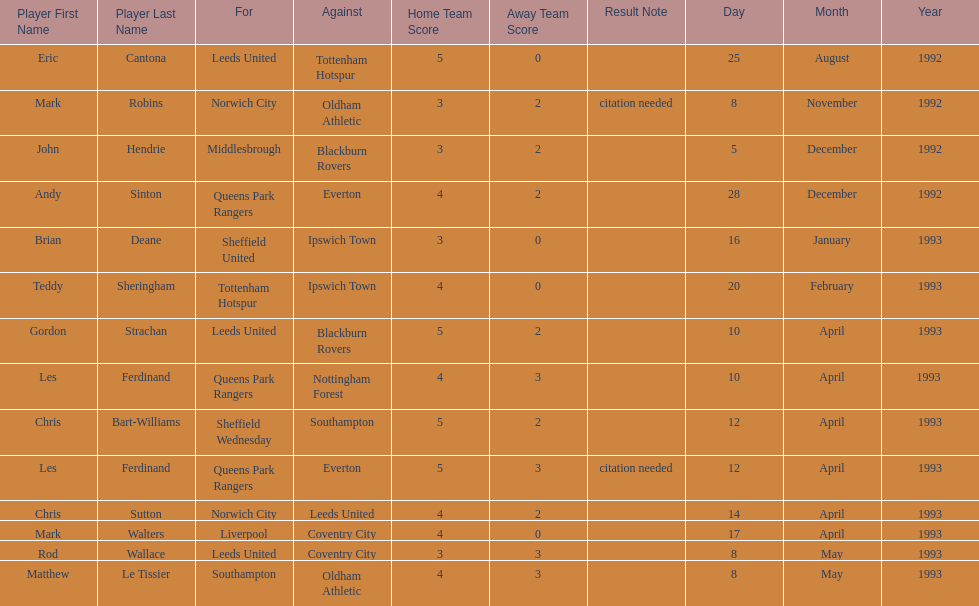How many players were for leeds united? 3. 